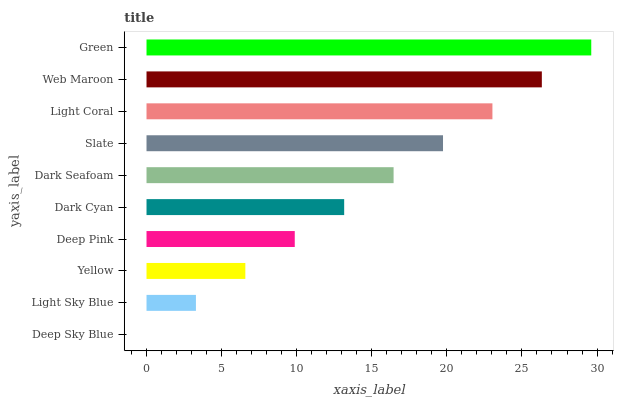Is Deep Sky Blue the minimum?
Answer yes or no. Yes. Is Green the maximum?
Answer yes or no. Yes. Is Light Sky Blue the minimum?
Answer yes or no. No. Is Light Sky Blue the maximum?
Answer yes or no. No. Is Light Sky Blue greater than Deep Sky Blue?
Answer yes or no. Yes. Is Deep Sky Blue less than Light Sky Blue?
Answer yes or no. Yes. Is Deep Sky Blue greater than Light Sky Blue?
Answer yes or no. No. Is Light Sky Blue less than Deep Sky Blue?
Answer yes or no. No. Is Dark Seafoam the high median?
Answer yes or no. Yes. Is Dark Cyan the low median?
Answer yes or no. Yes. Is Yellow the high median?
Answer yes or no. No. Is Light Coral the low median?
Answer yes or no. No. 